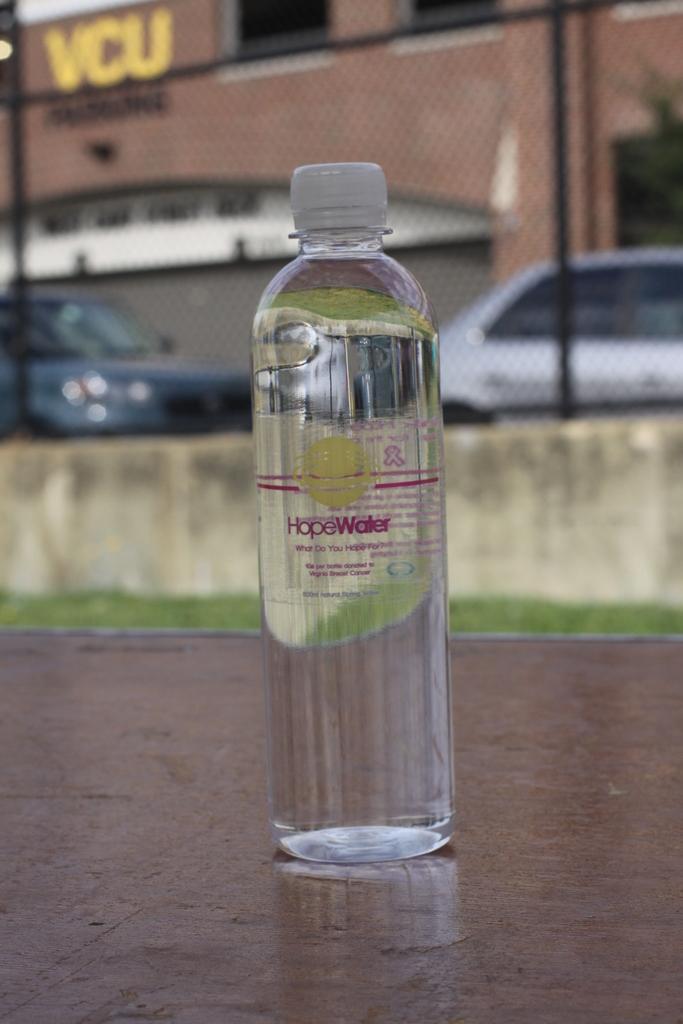Please provide a concise description of this image. This bottle is highlighted in this picture. Far there are vehicles. This is a building. 